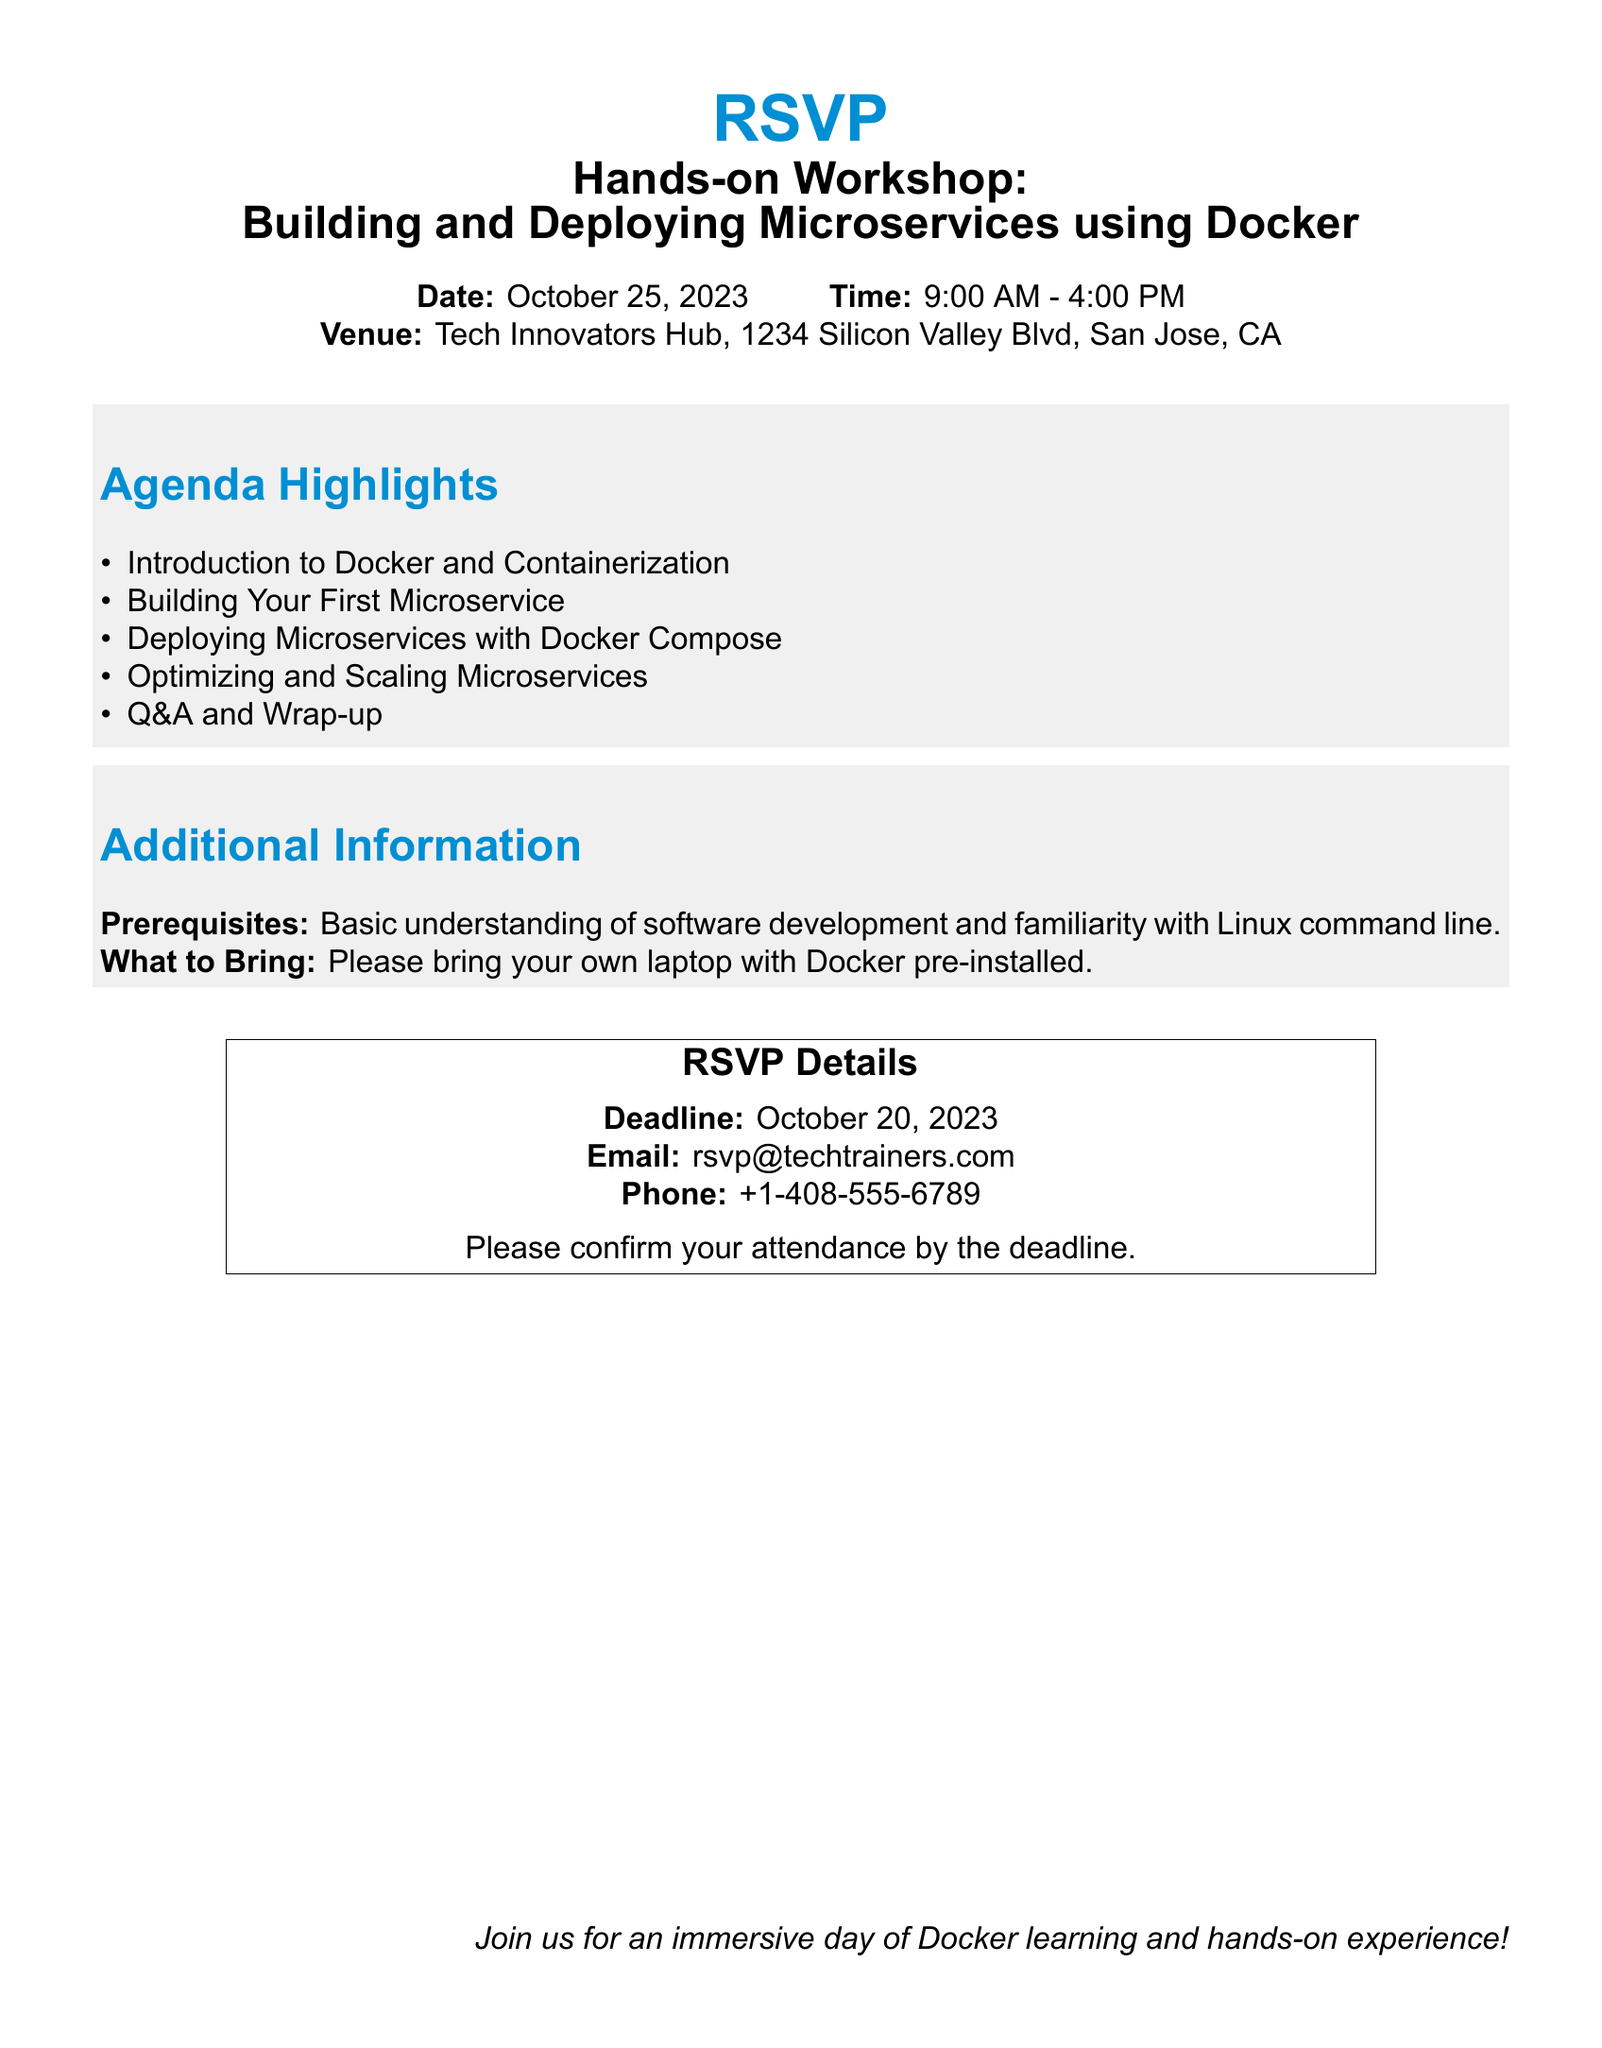What is the date of the workshop? The date of the workshop is provided in the document, which states "October 25, 2023."
Answer: October 25, 2023 What time does the workshop start? The document specifies the workshop time as "9:00 AM - 4:00 PM."
Answer: 9:00 AM Where is the workshop venue located? The venue for the workshop is detailed in the document as "Tech Innovators Hub, 1234 Silicon Valley Blvd, San Jose, CA."
Answer: Tech Innovators Hub, 1234 Silicon Valley Blvd, San Jose, CA What is one requirement to attend the workshop? The document mentions a prerequisite: "Basic understanding of software development and familiarity with Linux command line."
Answer: Basic understanding of software development What must participants bring to the workshop? The document advises participants to "bring your own laptop with Docker pre-installed."
Answer: own laptop with Docker pre-installed What is the RSVP deadline? The deadline for RSVP is clearly stated in the document as "October 20, 2023."
Answer: October 20, 2023 What is the email address for RSVP? The document provides the email address for RSVP as "rsvp@techtrainers.com."
Answer: rsvp@techtrainers.com How many agenda highlights are listed? The document lists five items under the "Agenda Highlights" section.
Answer: five 